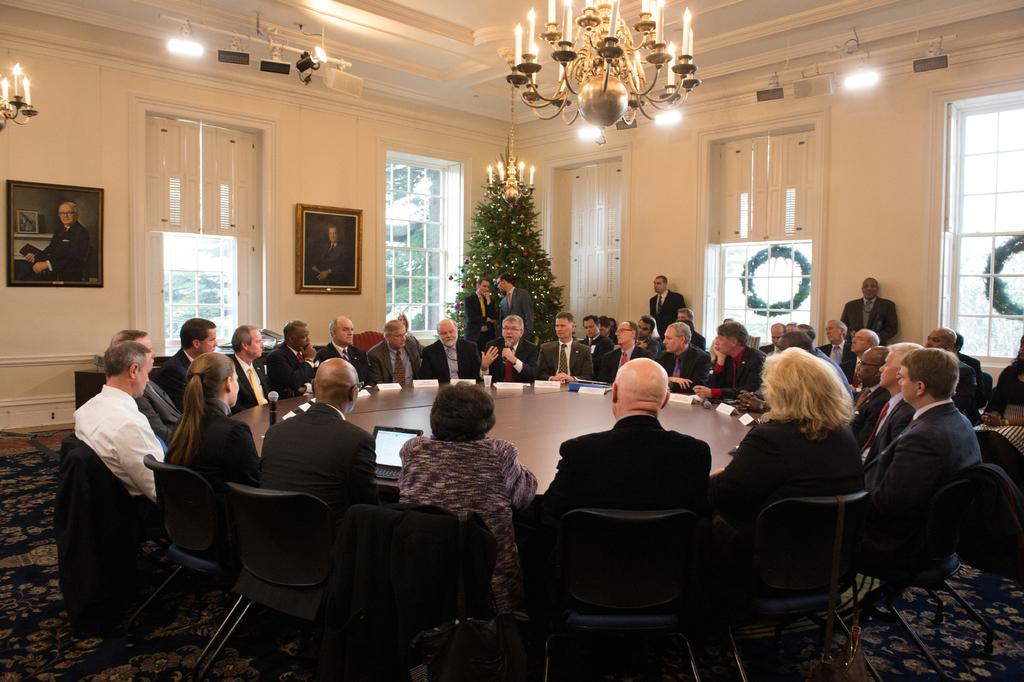What objects can be seen in the image that provide light? There are candles and a chandelier in the image that provide light. What type of structure is visible in the image? There is a wall in the image. What items are used for displaying photographs or artwork? There are photo frames in the image. What architectural feature allows natural light to enter the room? There is a window in the image. What is present on the table in the image? There is a poster and a laptop on the table. What are the people in the image doing? The people are sitting around a table on chairs. What type of plate is being used to serve the stew in the image? There is no plate or stew present in the image. How does the transport system function in the image? There is no transport system present in the image. 